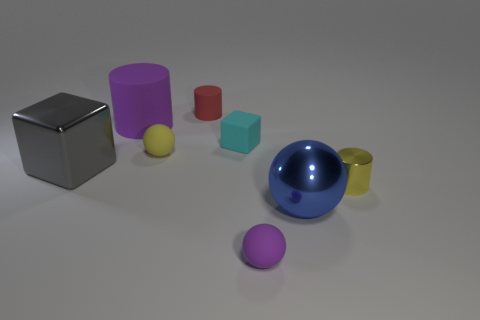Subtract 1 spheres. How many spheres are left? 2 Subtract all tiny matte balls. How many balls are left? 1 Add 1 purple balls. How many objects exist? 9 Subtract all cyan cylinders. Subtract all purple spheres. How many cylinders are left? 3 Subtract all blocks. How many objects are left? 6 Subtract all tiny yellow shiny spheres. Subtract all matte blocks. How many objects are left? 7 Add 4 big gray blocks. How many big gray blocks are left? 5 Add 3 purple matte blocks. How many purple matte blocks exist? 3 Subtract 0 cyan balls. How many objects are left? 8 